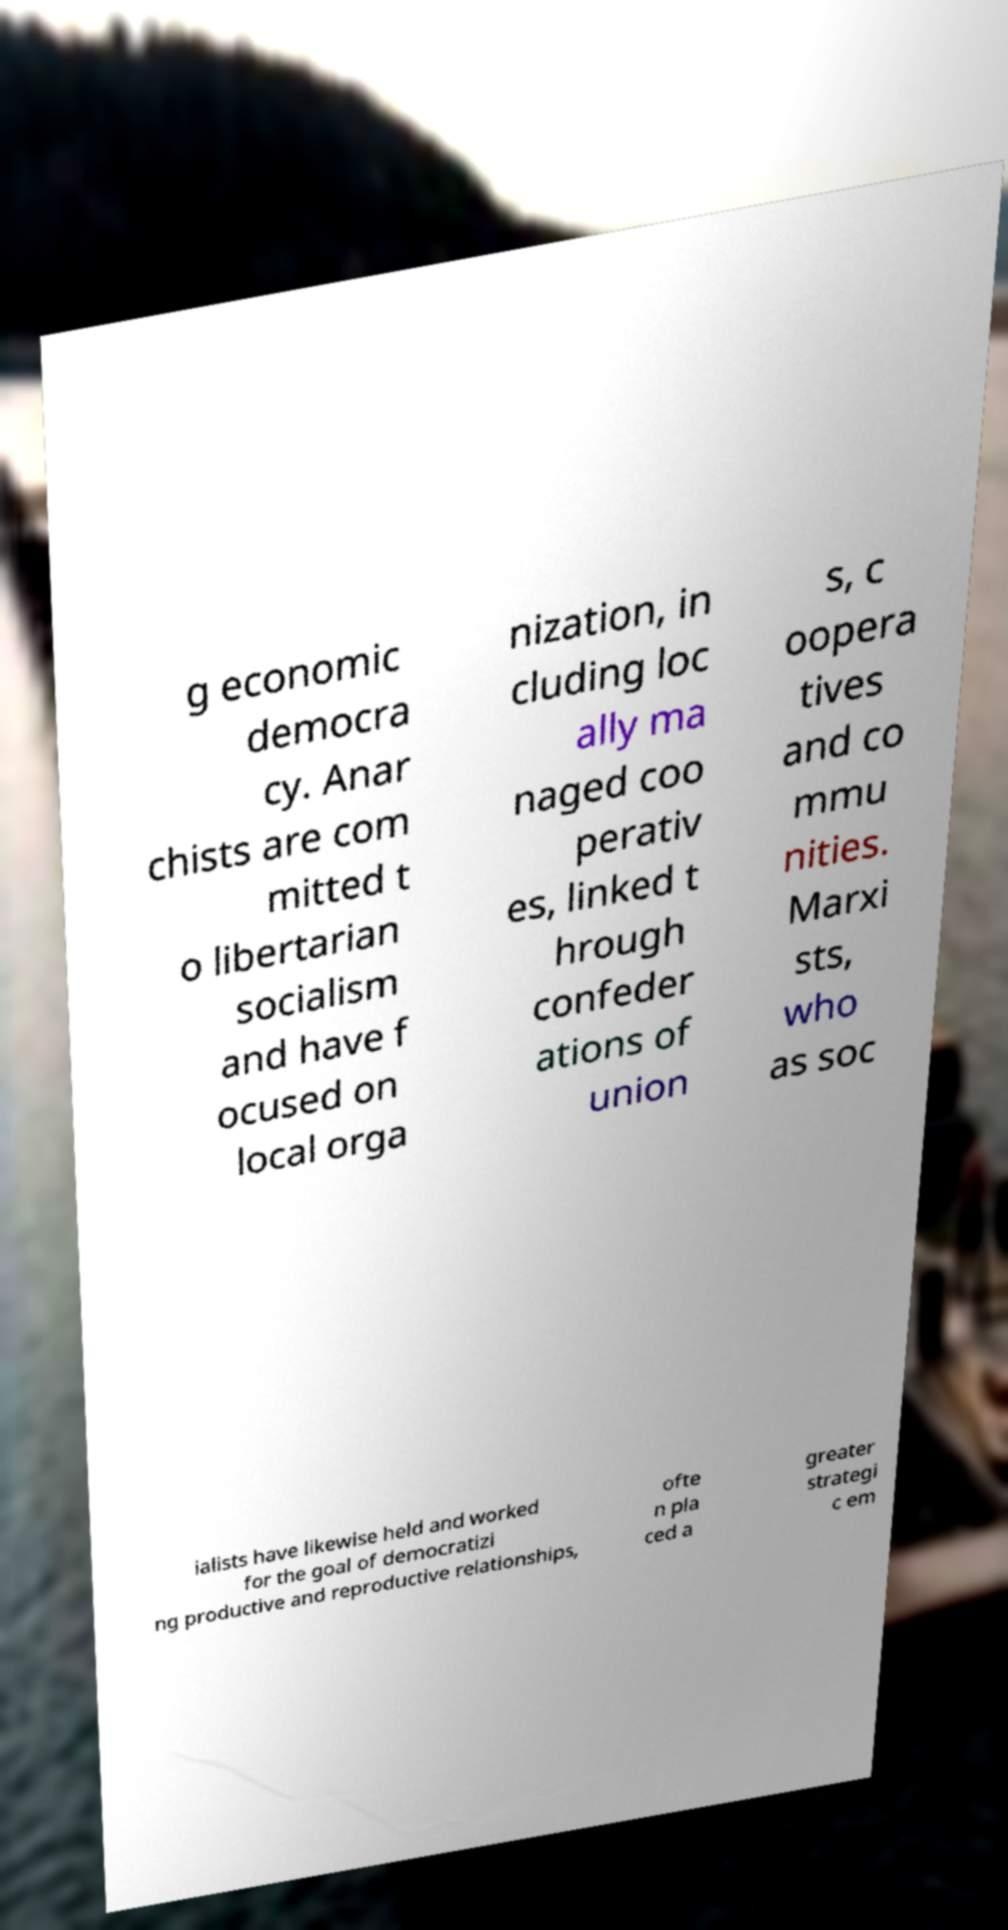For documentation purposes, I need the text within this image transcribed. Could you provide that? g economic democra cy. Anar chists are com mitted t o libertarian socialism and have f ocused on local orga nization, in cluding loc ally ma naged coo perativ es, linked t hrough confeder ations of union s, c oopera tives and co mmu nities. Marxi sts, who as soc ialists have likewise held and worked for the goal of democratizi ng productive and reproductive relationships, ofte n pla ced a greater strategi c em 